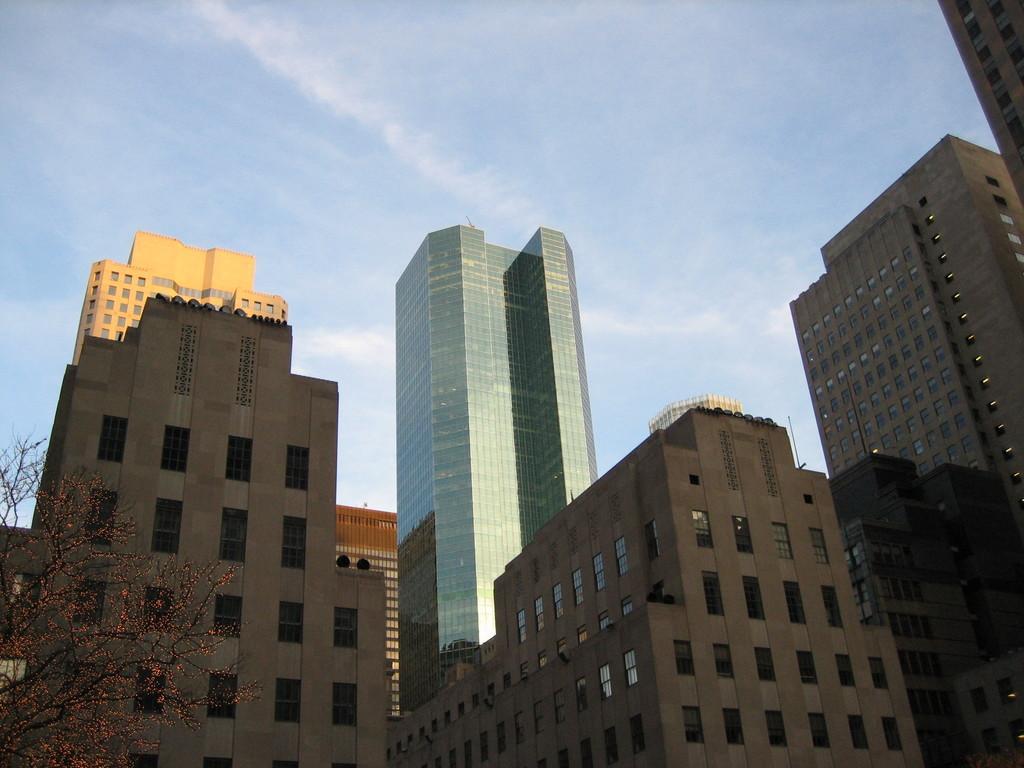Could you give a brief overview of what you see in this image? In the foreground I can see buildings and a tree. On the top I can see the sky. This image is taken during a day. 